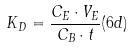Convert formula to latex. <formula><loc_0><loc_0><loc_500><loc_500>K _ { D } = \frac { C _ { E } \cdot V _ { E } } { C _ { B } \cdot t } ( 6 d )</formula> 